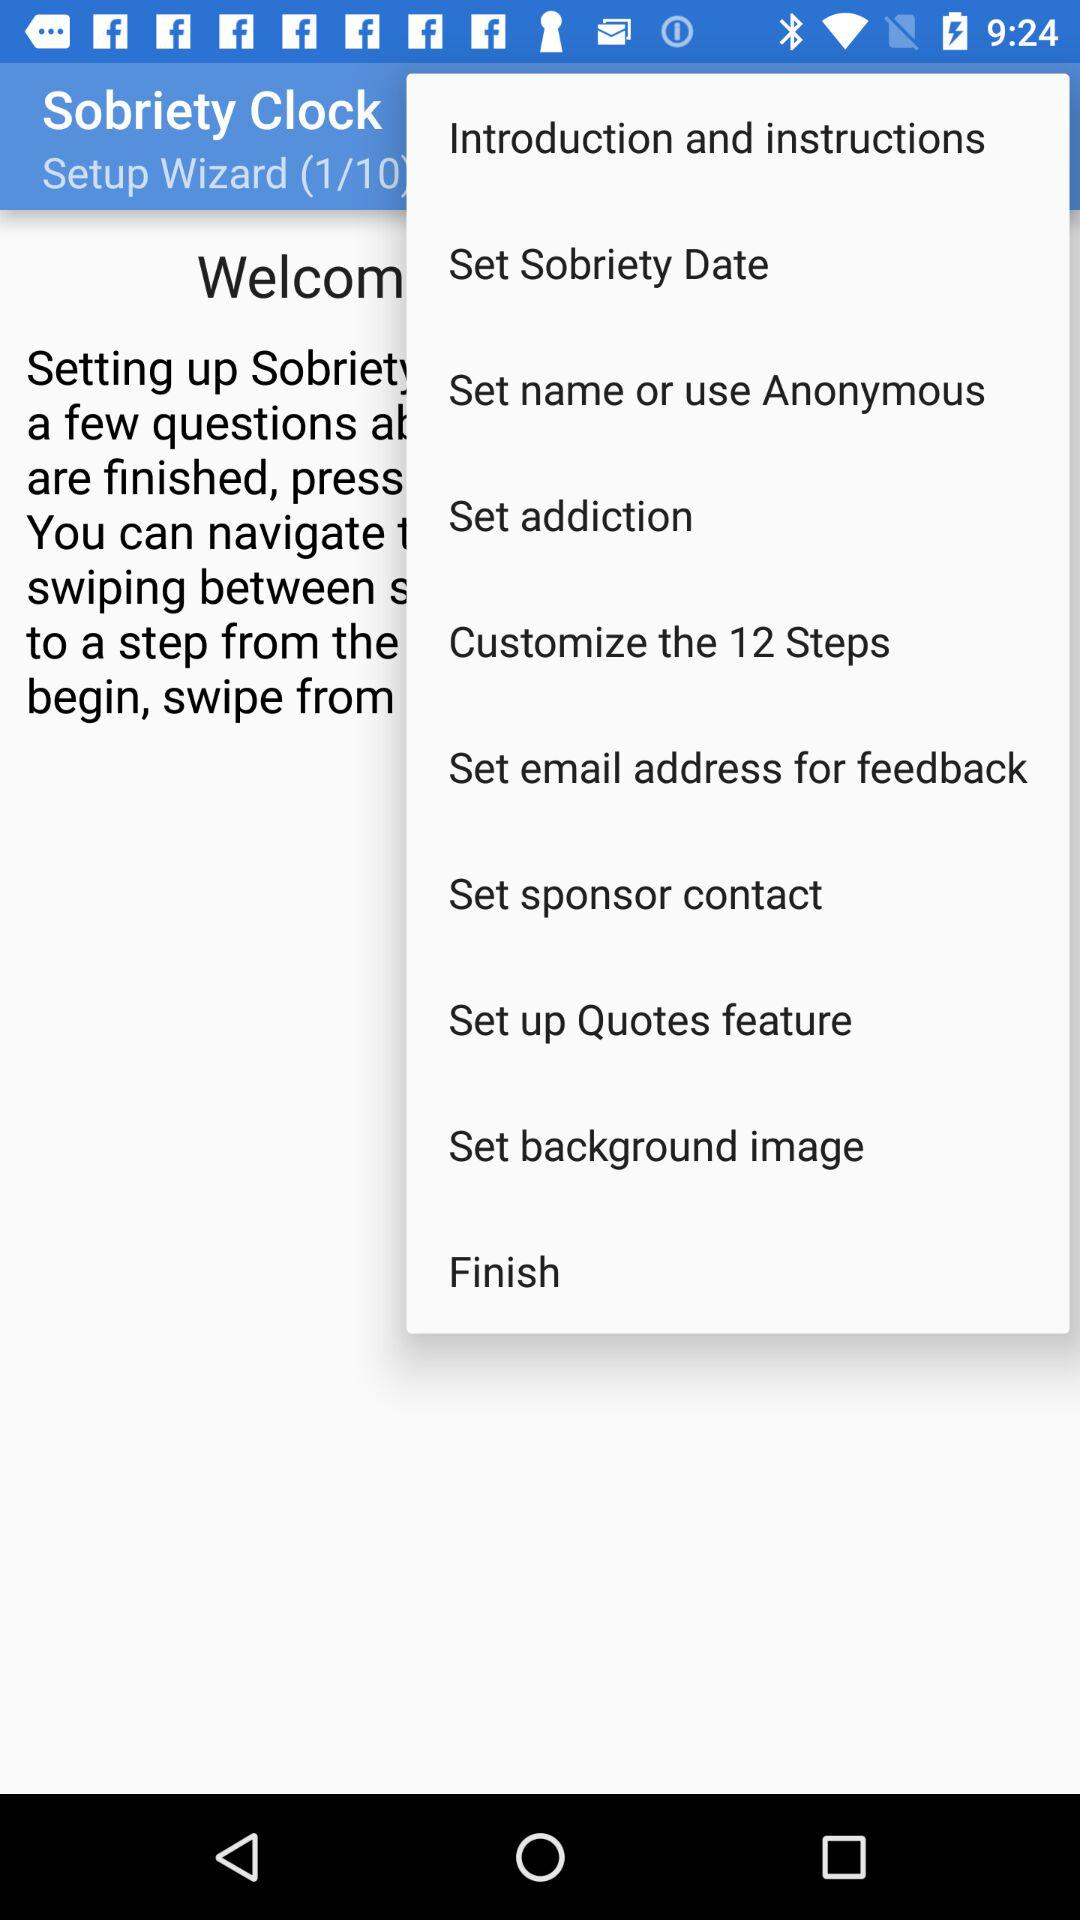What is the current page of the "Setup Wizard"? The current page is 1. 